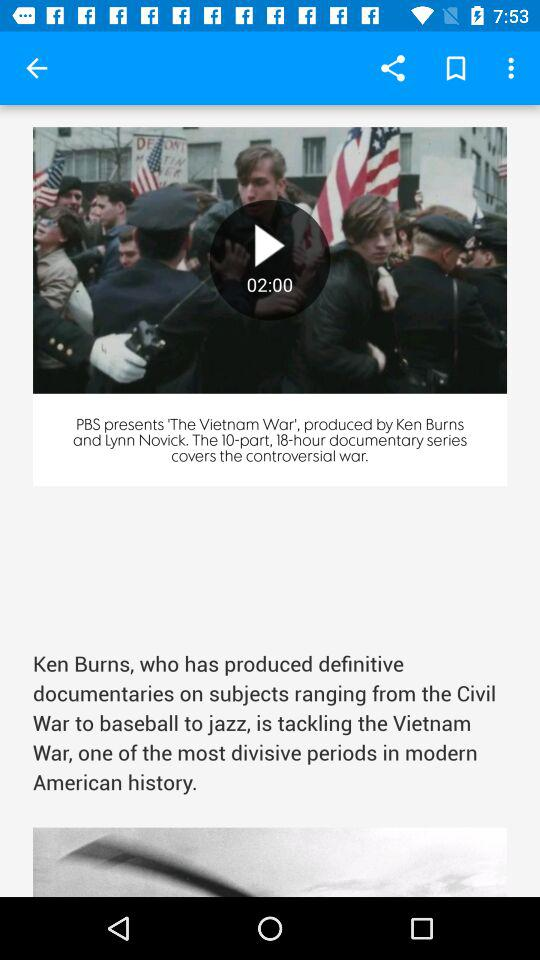What's the video duration? The video duration is 2:00. 